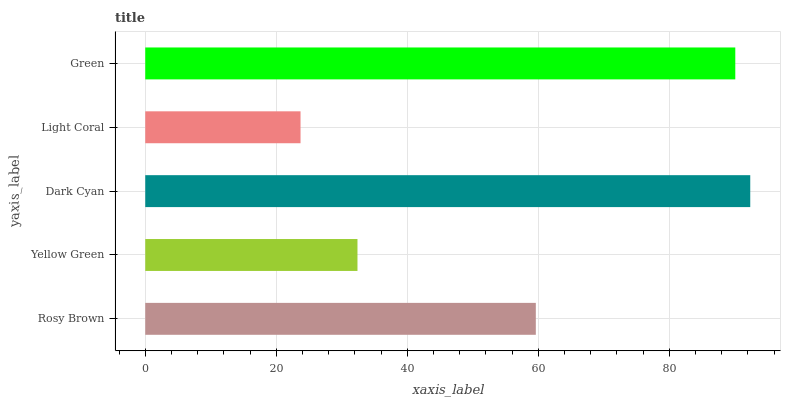Is Light Coral the minimum?
Answer yes or no. Yes. Is Dark Cyan the maximum?
Answer yes or no. Yes. Is Yellow Green the minimum?
Answer yes or no. No. Is Yellow Green the maximum?
Answer yes or no. No. Is Rosy Brown greater than Yellow Green?
Answer yes or no. Yes. Is Yellow Green less than Rosy Brown?
Answer yes or no. Yes. Is Yellow Green greater than Rosy Brown?
Answer yes or no. No. Is Rosy Brown less than Yellow Green?
Answer yes or no. No. Is Rosy Brown the high median?
Answer yes or no. Yes. Is Rosy Brown the low median?
Answer yes or no. Yes. Is Light Coral the high median?
Answer yes or no. No. Is Light Coral the low median?
Answer yes or no. No. 